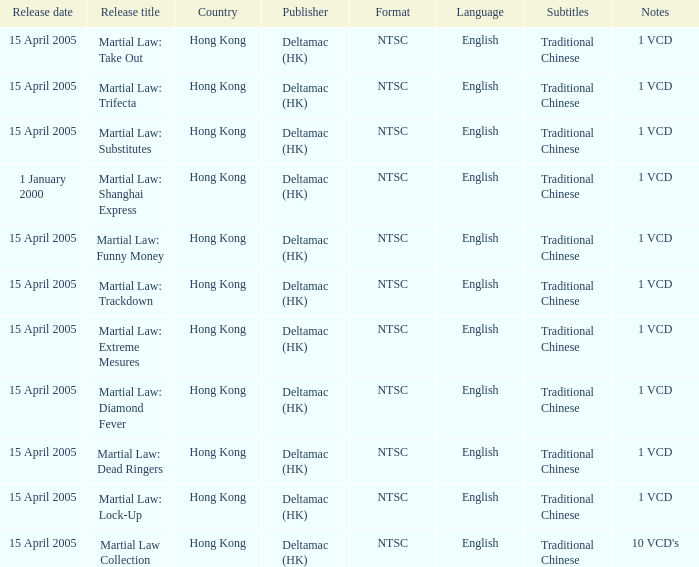What is the release date of Martial Law: Take Out? 15 April 2005. 